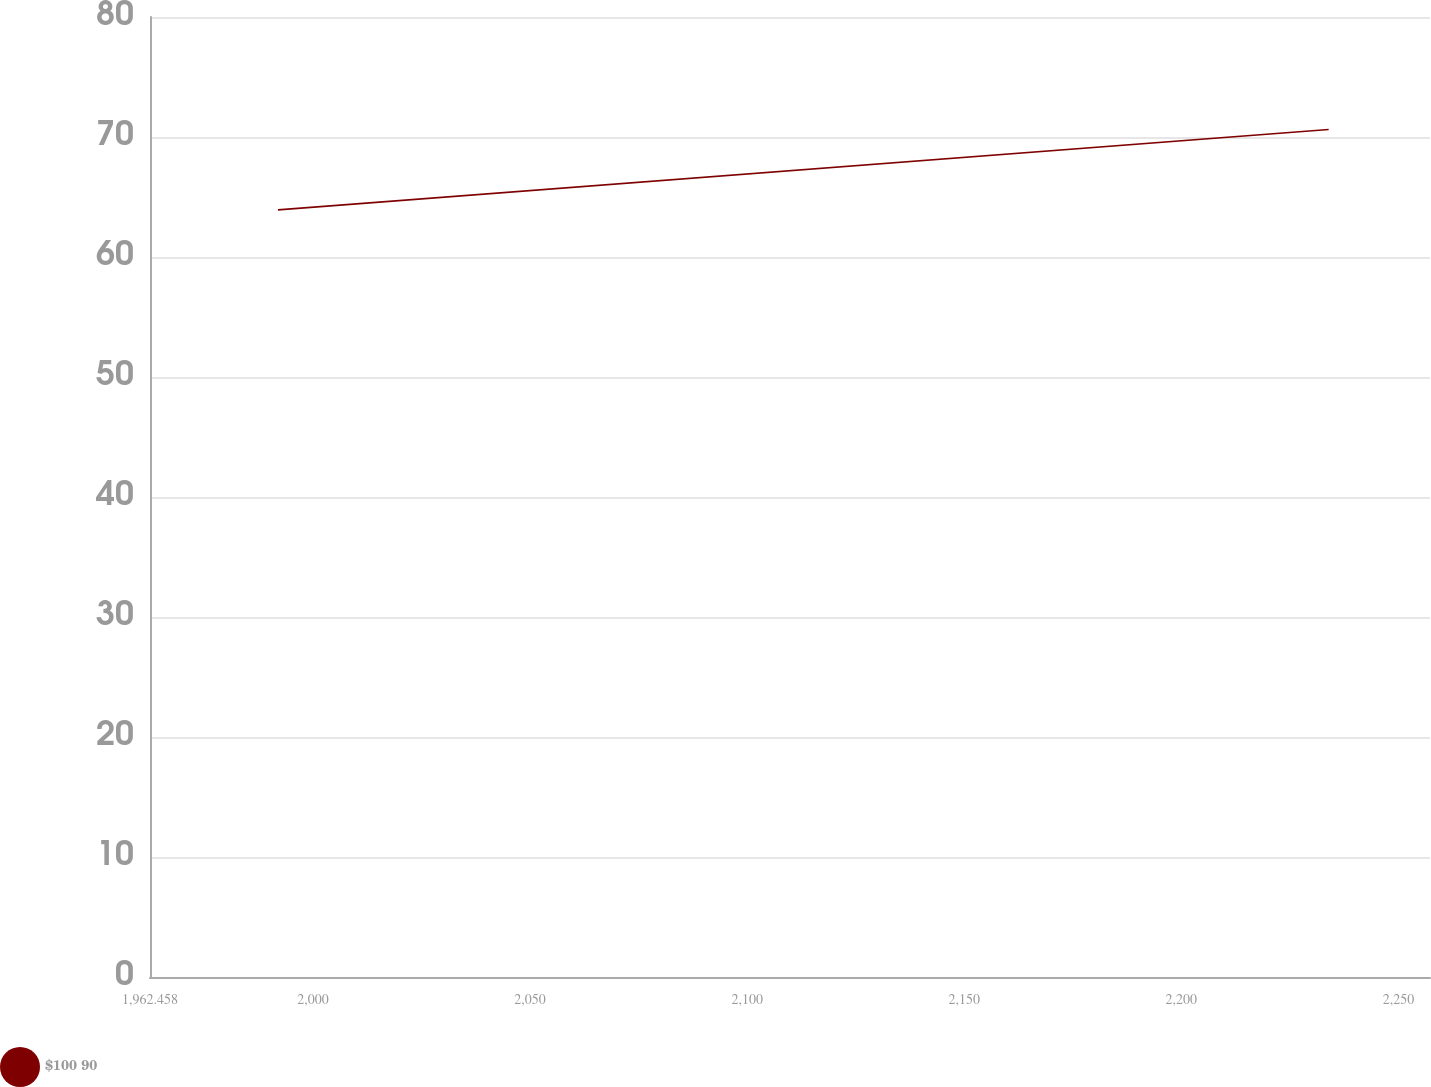<chart> <loc_0><loc_0><loc_500><loc_500><line_chart><ecel><fcel>$100 90<nl><fcel>1991.94<fcel>63.93<nl><fcel>2233.94<fcel>70.63<nl><fcel>2286.76<fcel>67.92<nl></chart> 